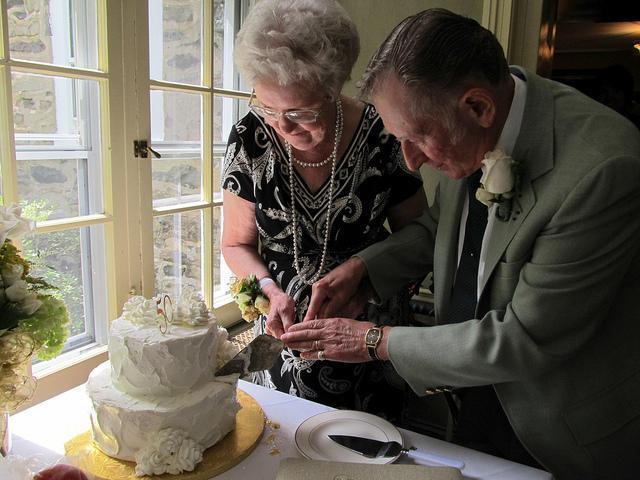How many people are visible?
Give a very brief answer. 2. How many cakes can you see?
Give a very brief answer. 1. How many chairs are there?
Give a very brief answer. 0. 